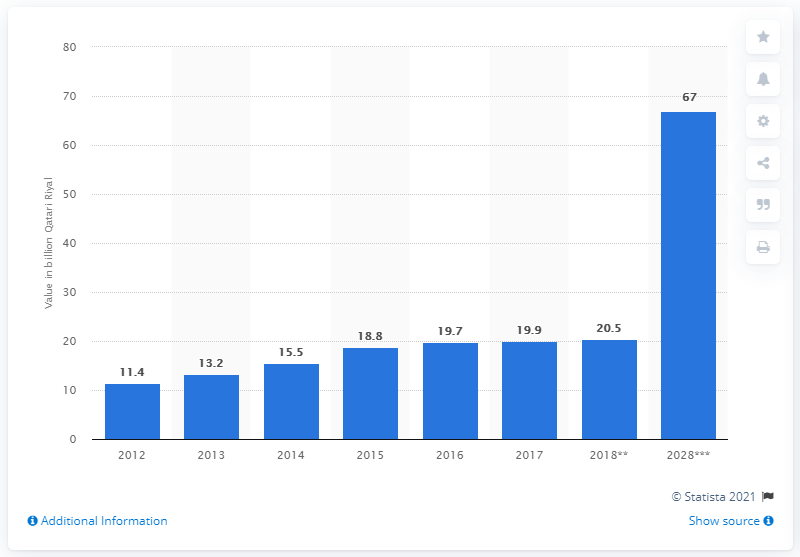Point out several critical features in this image. By 2028, travel and tourism is projected to contribute 67% of Qatar's GDP, indicating the significant economic impact of the industry on the country. 